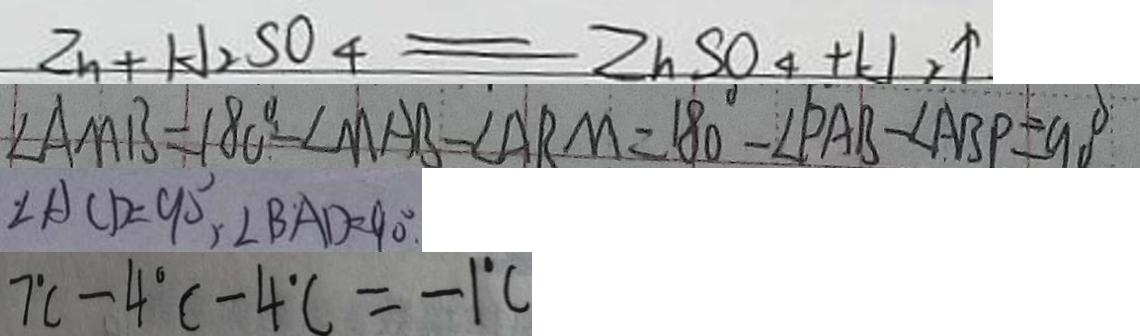<formula> <loc_0><loc_0><loc_500><loc_500>Z n + H _ { 2 } S O _ { 4 } = Z n S O _ { 4 } + H _ { 2 } \uparrow 
 \angle A M B = 1 8 0 ^ { \circ } - \angle M A B - \angle A R M = 1 8 0 ^ { \circ } - \angle P A B - \angle A B P = 9 0 ^ { \circ } 
 \angle A C D = 9 0 ^ { \circ } , \angle B A D = 9 0 ^ { \circ } . 
 7 ^ { \circ } C - 4 ^ { \circ } C - 4 ^ { \circ } C = - 1 ^ { \circ } C</formula> 